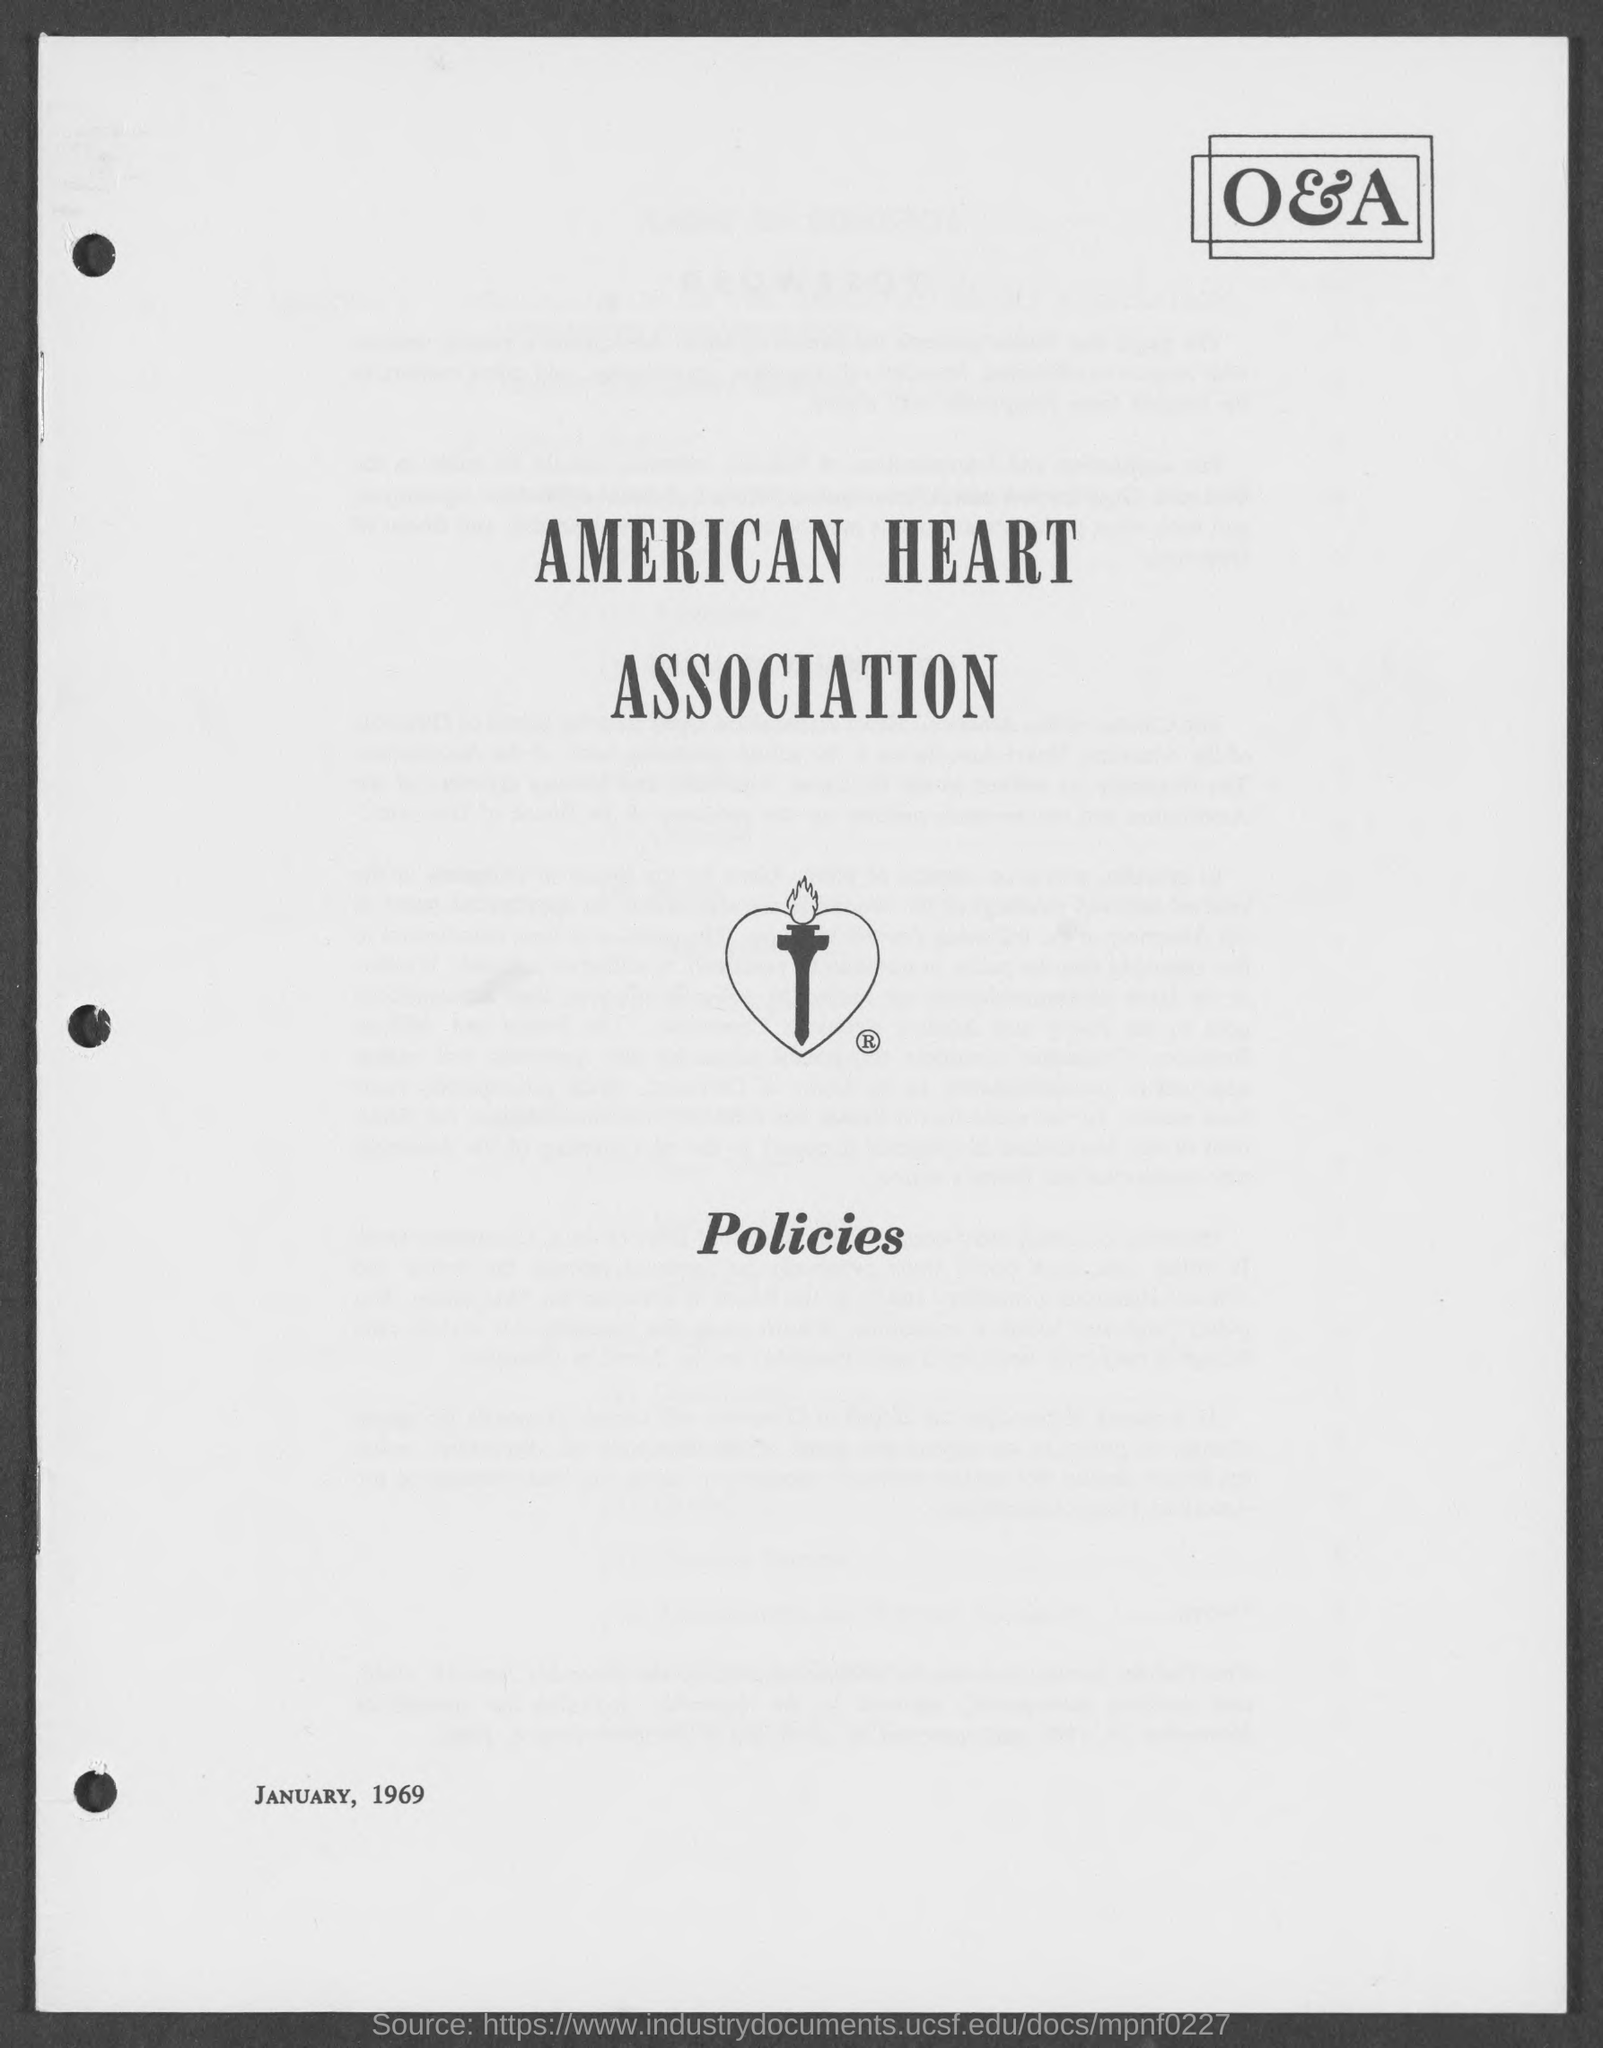Mention a couple of crucial points in this snapshot. The American Heart Association is the name of the heart association. 